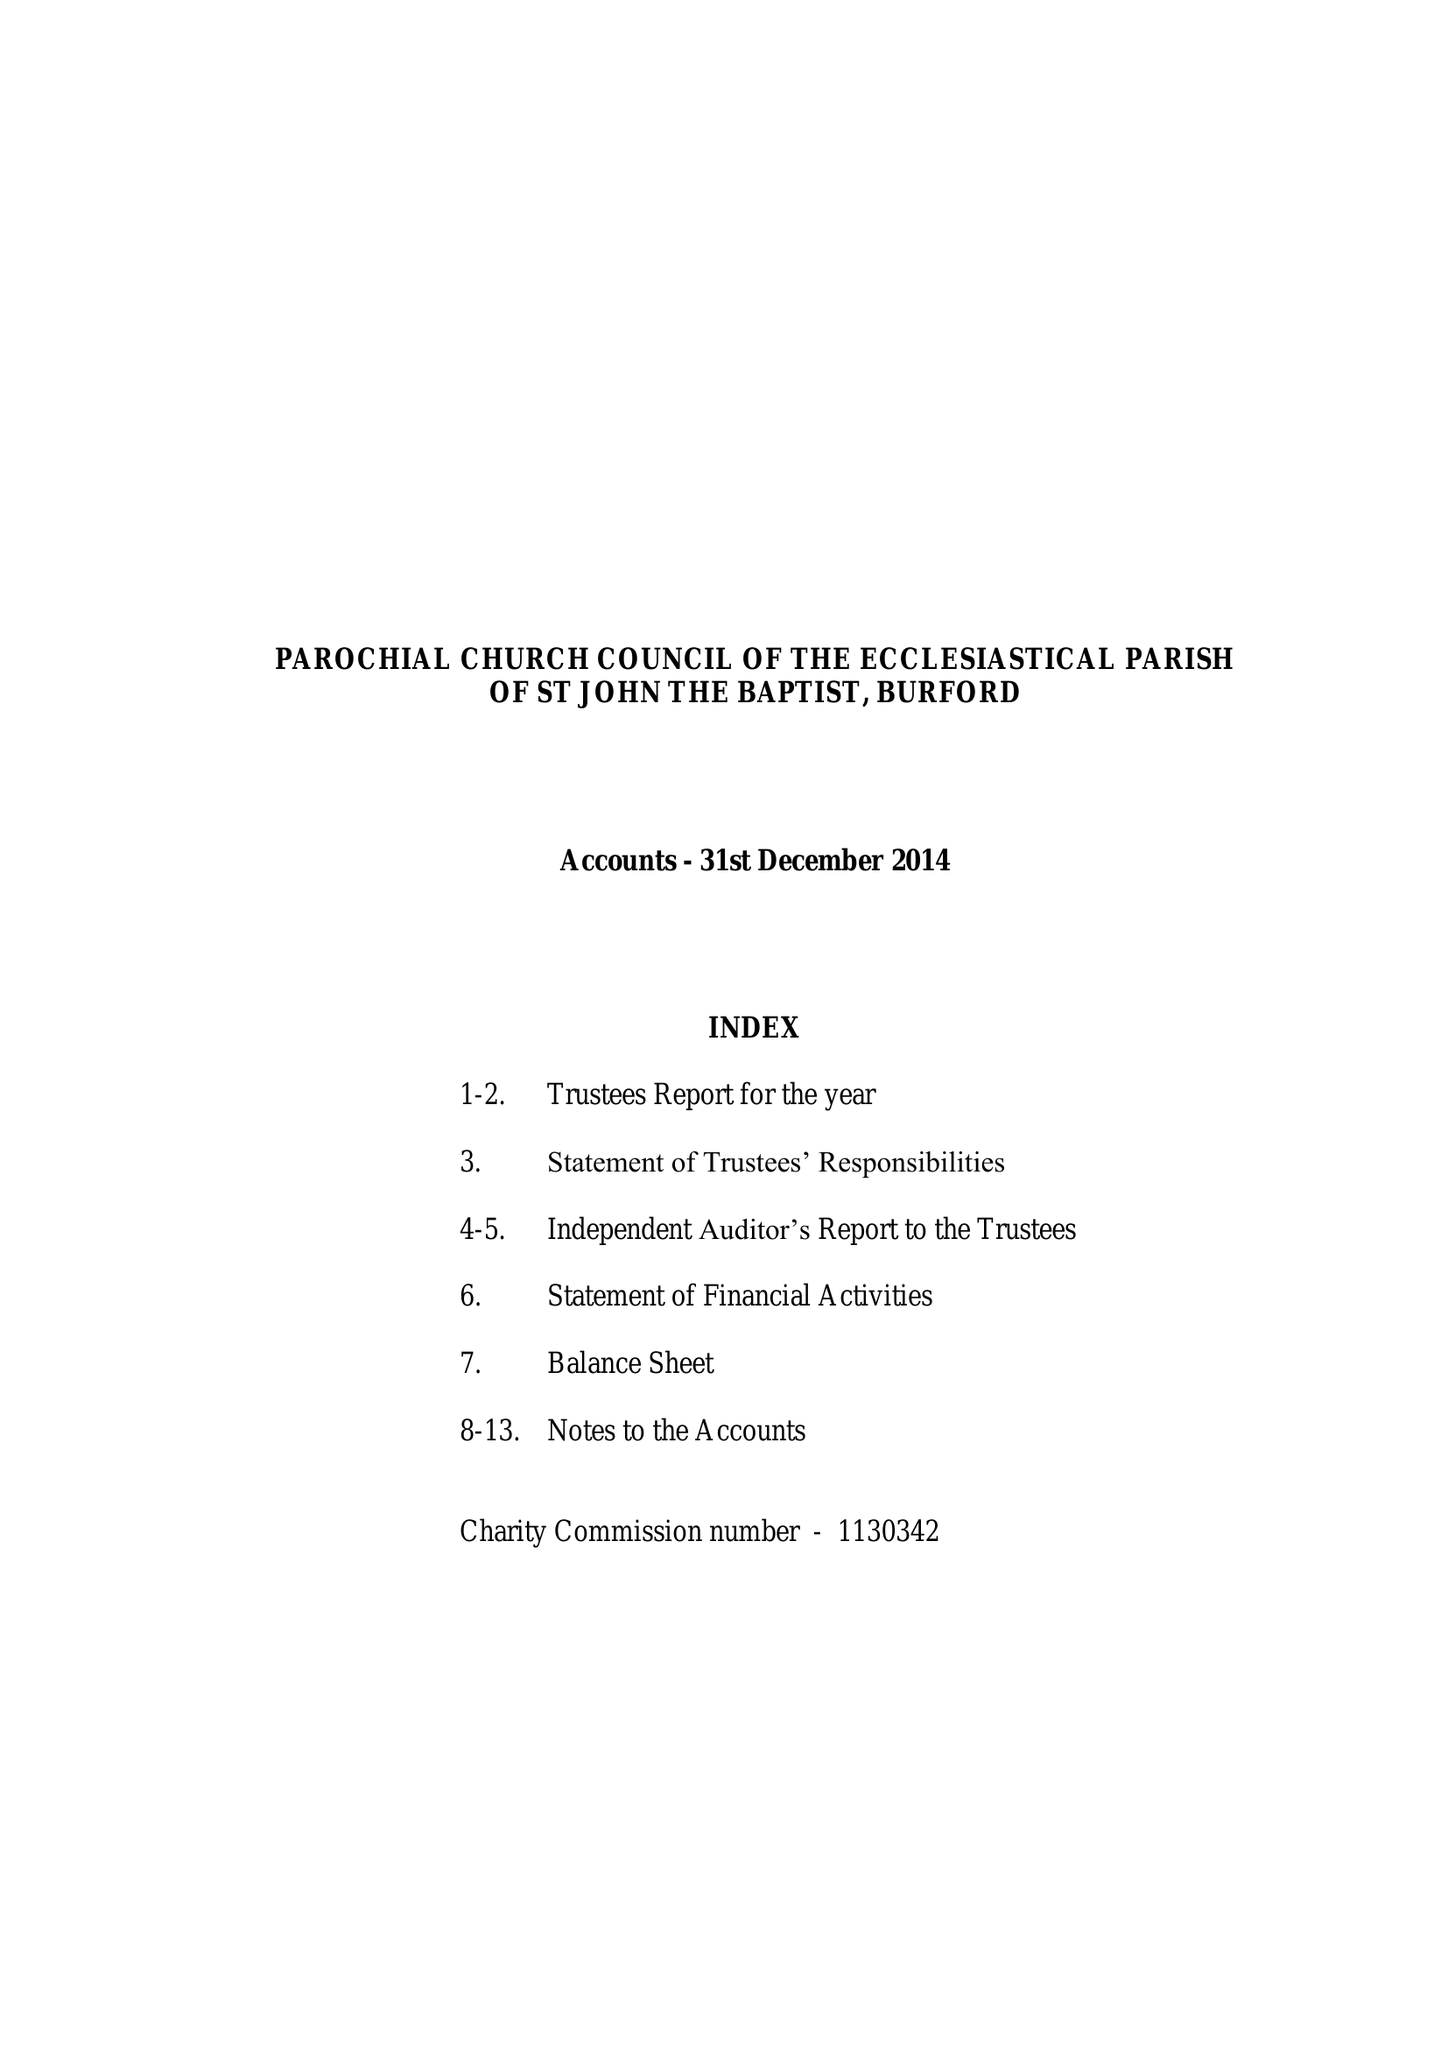What is the value for the charity_name?
Answer the question using a single word or phrase. The Parochial Church Council Of The Ecclesiastical Parish Of St John The Baptist, Burford 